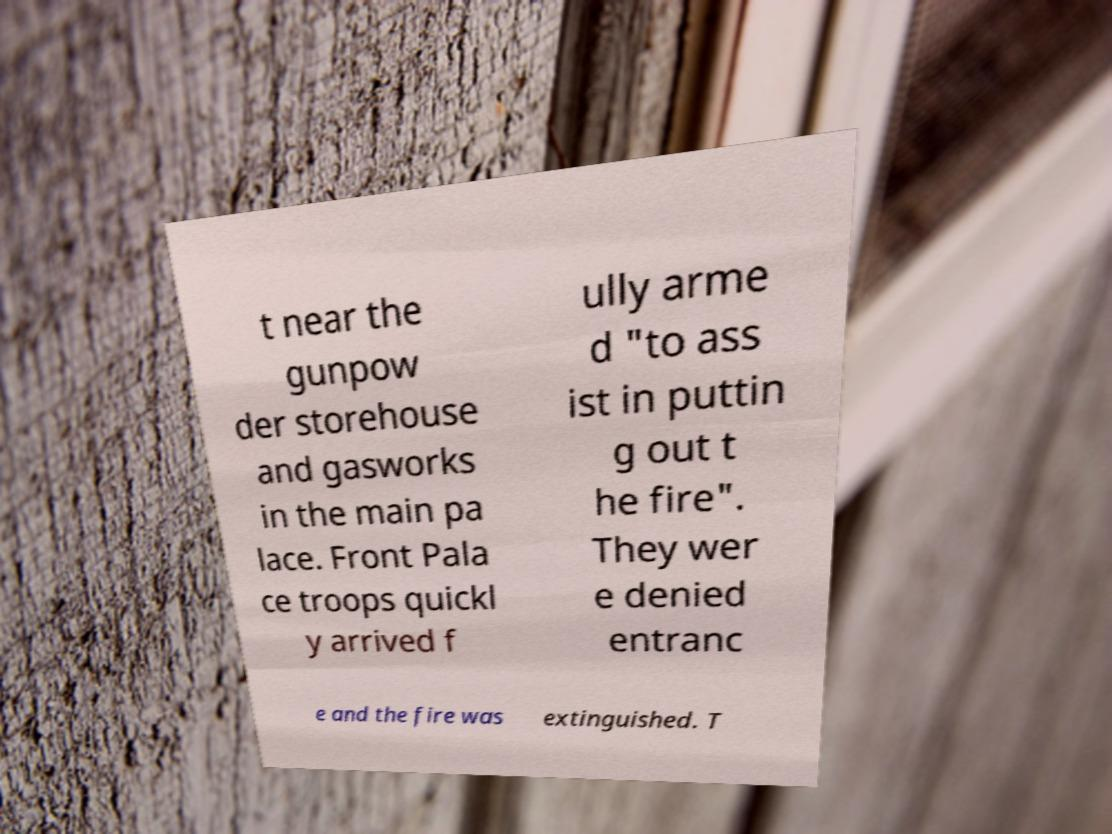Can you accurately transcribe the text from the provided image for me? t near the gunpow der storehouse and gasworks in the main pa lace. Front Pala ce troops quickl y arrived f ully arme d "to ass ist in puttin g out t he fire". They wer e denied entranc e and the fire was extinguished. T 